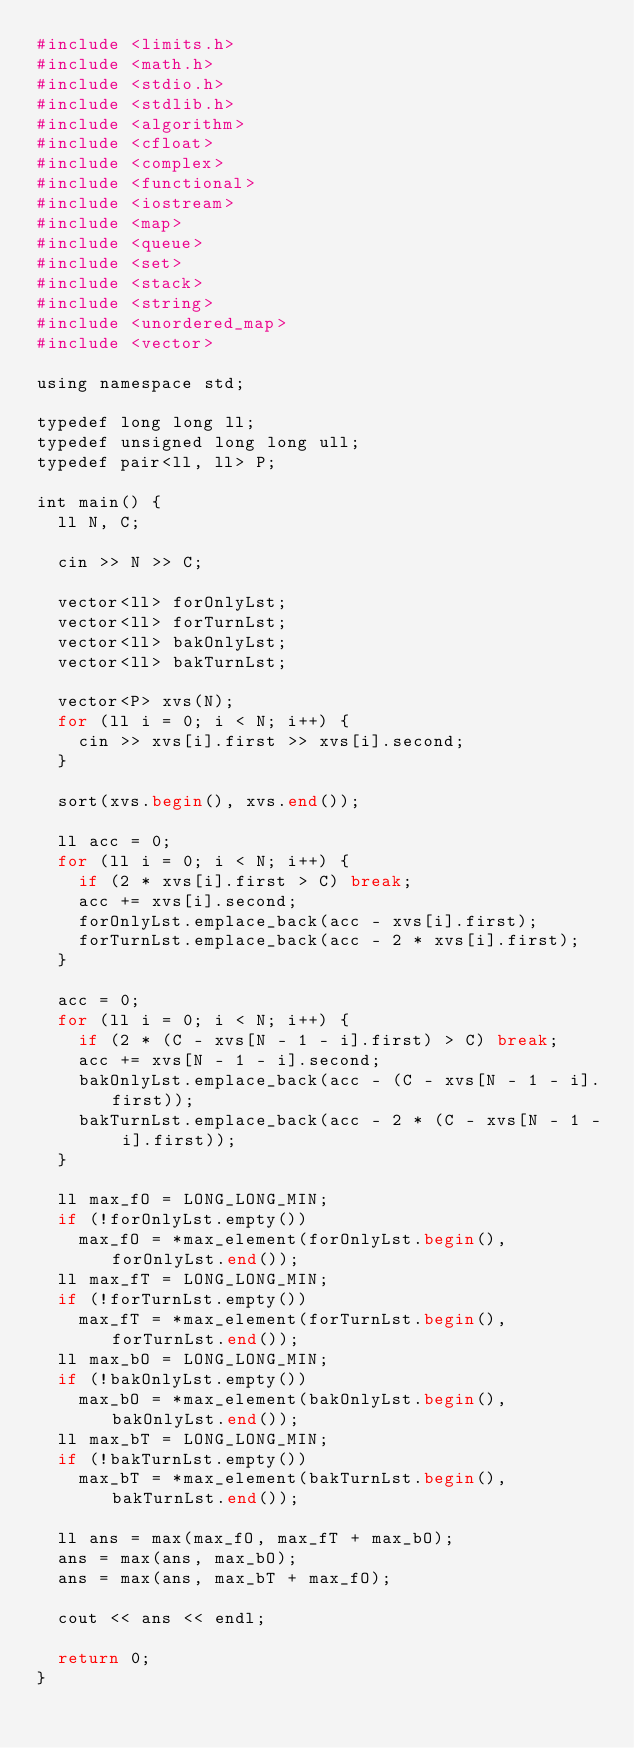<code> <loc_0><loc_0><loc_500><loc_500><_Ruby_>#include <limits.h>
#include <math.h>
#include <stdio.h>
#include <stdlib.h>
#include <algorithm>
#include <cfloat>
#include <complex>
#include <functional>
#include <iostream>
#include <map>
#include <queue>
#include <set>
#include <stack>
#include <string>
#include <unordered_map>
#include <vector>

using namespace std;

typedef long long ll;
typedef unsigned long long ull;
typedef pair<ll, ll> P;

int main() {
  ll N, C;

  cin >> N >> C;

  vector<ll> forOnlyLst;
  vector<ll> forTurnLst;
  vector<ll> bakOnlyLst;
  vector<ll> bakTurnLst;

  vector<P> xvs(N);
  for (ll i = 0; i < N; i++) {
    cin >> xvs[i].first >> xvs[i].second;
  }

  sort(xvs.begin(), xvs.end());

  ll acc = 0;
  for (ll i = 0; i < N; i++) {
    if (2 * xvs[i].first > C) break;
    acc += xvs[i].second;
    forOnlyLst.emplace_back(acc - xvs[i].first);
    forTurnLst.emplace_back(acc - 2 * xvs[i].first);
  }

  acc = 0;
  for (ll i = 0; i < N; i++) {
    if (2 * (C - xvs[N - 1 - i].first) > C) break;
    acc += xvs[N - 1 - i].second;
    bakOnlyLst.emplace_back(acc - (C - xvs[N - 1 - i].first));
    bakTurnLst.emplace_back(acc - 2 * (C - xvs[N - 1 - i].first));
  }

  ll max_fO = LONG_LONG_MIN;
  if (!forOnlyLst.empty())
    max_fO = *max_element(forOnlyLst.begin(), forOnlyLst.end());
  ll max_fT = LONG_LONG_MIN;
  if (!forTurnLst.empty())
    max_fT = *max_element(forTurnLst.begin(), forTurnLst.end());
  ll max_bO = LONG_LONG_MIN;
  if (!bakOnlyLst.empty())
    max_bO = *max_element(bakOnlyLst.begin(), bakOnlyLst.end());
  ll max_bT = LONG_LONG_MIN;
  if (!bakTurnLst.empty())
    max_bT = *max_element(bakTurnLst.begin(), bakTurnLst.end());

  ll ans = max(max_fO, max_fT + max_bO);
  ans = max(ans, max_bO);
  ans = max(ans, max_bT + max_fO);

  cout << ans << endl;

  return 0;
}
</code> 